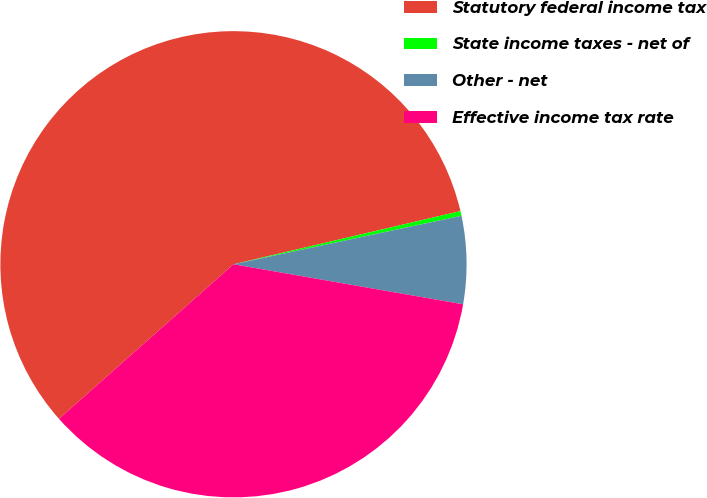Convert chart to OTSL. <chart><loc_0><loc_0><loc_500><loc_500><pie_chart><fcel>Statutory federal income tax<fcel>State income taxes - net of<fcel>Other - net<fcel>Effective income tax rate<nl><fcel>57.87%<fcel>0.33%<fcel>6.08%<fcel>35.71%<nl></chart> 